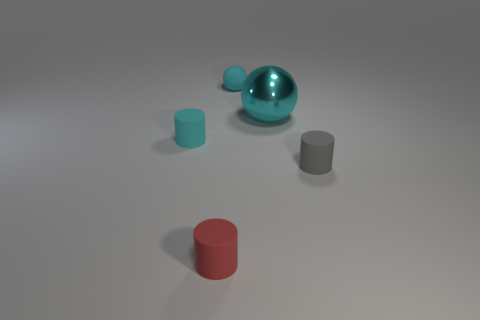Add 2 small blue matte balls. How many objects exist? 7 Subtract all cylinders. How many objects are left? 2 Add 2 cyan rubber objects. How many cyan rubber objects exist? 4 Subtract 1 cyan balls. How many objects are left? 4 Subtract all tiny things. Subtract all tiny cyan matte cylinders. How many objects are left? 0 Add 3 cyan metallic things. How many cyan metallic things are left? 4 